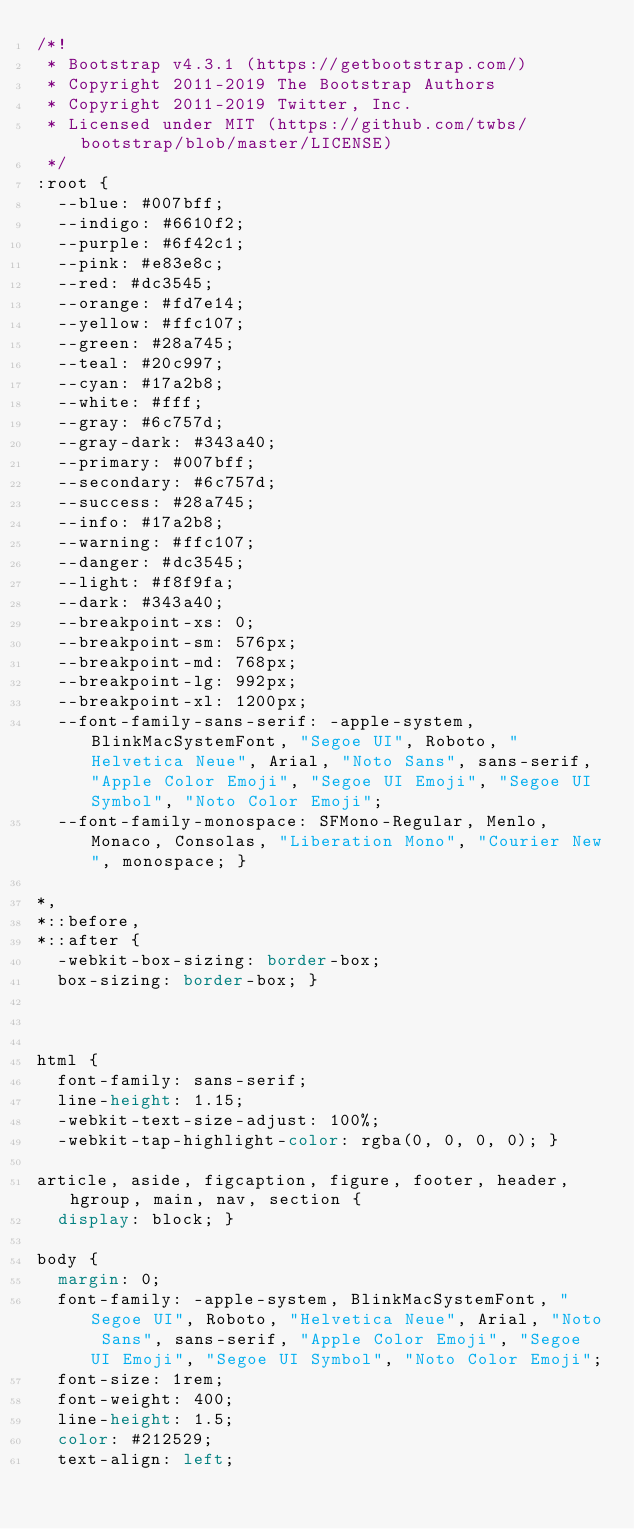<code> <loc_0><loc_0><loc_500><loc_500><_CSS_>/*!
 * Bootstrap v4.3.1 (https://getbootstrap.com/)
 * Copyright 2011-2019 The Bootstrap Authors
 * Copyright 2011-2019 Twitter, Inc.
 * Licensed under MIT (https://github.com/twbs/bootstrap/blob/master/LICENSE)
 */
:root {
  --blue: #007bff;
  --indigo: #6610f2;
  --purple: #6f42c1;
  --pink: #e83e8c;
  --red: #dc3545;
  --orange: #fd7e14;
  --yellow: #ffc107;
  --green: #28a745;
  --teal: #20c997;
  --cyan: #17a2b8;
  --white: #fff;
  --gray: #6c757d;
  --gray-dark: #343a40;
  --primary: #007bff;
  --secondary: #6c757d;
  --success: #28a745;
  --info: #17a2b8;
  --warning: #ffc107;
  --danger: #dc3545;
  --light: #f8f9fa;
  --dark: #343a40;
  --breakpoint-xs: 0;
  --breakpoint-sm: 576px;
  --breakpoint-md: 768px;
  --breakpoint-lg: 992px;
  --breakpoint-xl: 1200px;
  --font-family-sans-serif: -apple-system, BlinkMacSystemFont, "Segoe UI", Roboto, "Helvetica Neue", Arial, "Noto Sans", sans-serif, "Apple Color Emoji", "Segoe UI Emoji", "Segoe UI Symbol", "Noto Color Emoji";
  --font-family-monospace: SFMono-Regular, Menlo, Monaco, Consolas, "Liberation Mono", "Courier New", monospace; }

*,
*::before,
*::after {
  -webkit-box-sizing: border-box;
  box-sizing: border-box; }



html {
  font-family: sans-serif;
  line-height: 1.15;
  -webkit-text-size-adjust: 100%;
  -webkit-tap-highlight-color: rgba(0, 0, 0, 0); }

article, aside, figcaption, figure, footer, header, hgroup, main, nav, section {
  display: block; }

body {
  margin: 0;
  font-family: -apple-system, BlinkMacSystemFont, "Segoe UI", Roboto, "Helvetica Neue", Arial, "Noto Sans", sans-serif, "Apple Color Emoji", "Segoe UI Emoji", "Segoe UI Symbol", "Noto Color Emoji";
  font-size: 1rem;
  font-weight: 400;
  line-height: 1.5;
  color: #212529;
  text-align: left;</code> 